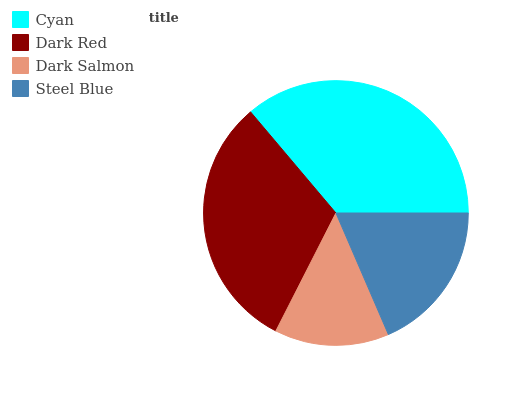Is Dark Salmon the minimum?
Answer yes or no. Yes. Is Cyan the maximum?
Answer yes or no. Yes. Is Dark Red the minimum?
Answer yes or no. No. Is Dark Red the maximum?
Answer yes or no. No. Is Cyan greater than Dark Red?
Answer yes or no. Yes. Is Dark Red less than Cyan?
Answer yes or no. Yes. Is Dark Red greater than Cyan?
Answer yes or no. No. Is Cyan less than Dark Red?
Answer yes or no. No. Is Dark Red the high median?
Answer yes or no. Yes. Is Steel Blue the low median?
Answer yes or no. Yes. Is Cyan the high median?
Answer yes or no. No. Is Dark Red the low median?
Answer yes or no. No. 